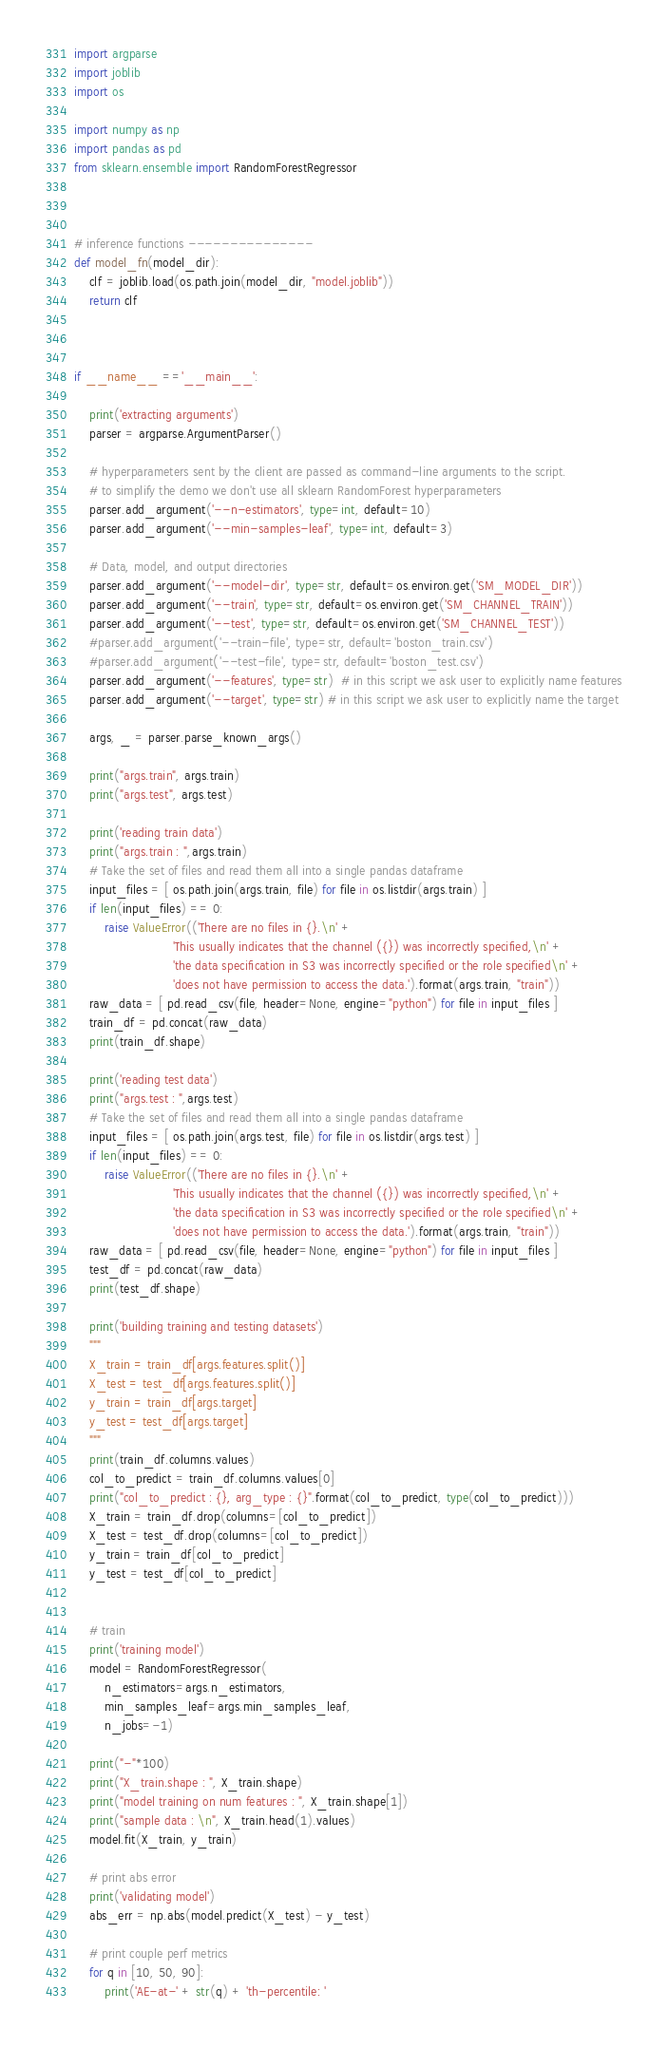<code> <loc_0><loc_0><loc_500><loc_500><_Python_>
import argparse
import joblib
import os

import numpy as np
import pandas as pd
from sklearn.ensemble import RandomForestRegressor



# inference functions ---------------
def model_fn(model_dir):
    clf = joblib.load(os.path.join(model_dir, "model.joblib"))
    return clf



if __name__ =='__main__':

    print('extracting arguments')
    parser = argparse.ArgumentParser()

    # hyperparameters sent by the client are passed as command-line arguments to the script.
    # to simplify the demo we don't use all sklearn RandomForest hyperparameters
    parser.add_argument('--n-estimators', type=int, default=10)
    parser.add_argument('--min-samples-leaf', type=int, default=3)

    # Data, model, and output directories
    parser.add_argument('--model-dir', type=str, default=os.environ.get('SM_MODEL_DIR'))
    parser.add_argument('--train', type=str, default=os.environ.get('SM_CHANNEL_TRAIN'))
    parser.add_argument('--test', type=str, default=os.environ.get('SM_CHANNEL_TEST'))
    #parser.add_argument('--train-file', type=str, default='boston_train.csv')
    #parser.add_argument('--test-file', type=str, default='boston_test.csv')
    parser.add_argument('--features', type=str)  # in this script we ask user to explicitly name features
    parser.add_argument('--target', type=str) # in this script we ask user to explicitly name the target

    args, _ = parser.parse_known_args()
    
    print("args.train", args.train)
    print("args.test", args.test)
    
    print('reading train data')
    print("args.train : ",args.train)
    # Take the set of files and read them all into a single pandas dataframe
    input_files = [ os.path.join(args.train, file) for file in os.listdir(args.train) ]
    if len(input_files) == 0:
        raise ValueError(('There are no files in {}.\n' +
                          'This usually indicates that the channel ({}) was incorrectly specified,\n' +
                          'the data specification in S3 was incorrectly specified or the role specified\n' +
                          'does not have permission to access the data.').format(args.train, "train"))
    raw_data = [ pd.read_csv(file, header=None, engine="python") for file in input_files ]
    train_df = pd.concat(raw_data)
    print(train_df.shape)
    
    print('reading test data')
    print("args.test : ",args.test)
    # Take the set of files and read them all into a single pandas dataframe
    input_files = [ os.path.join(args.test, file) for file in os.listdir(args.test) ]
    if len(input_files) == 0:
        raise ValueError(('There are no files in {}.\n' +
                          'This usually indicates that the channel ({}) was incorrectly specified,\n' +
                          'the data specification in S3 was incorrectly specified or the role specified\n' +
                          'does not have permission to access the data.').format(args.train, "train"))
    raw_data = [ pd.read_csv(file, header=None, engine="python") for file in input_files ]
    test_df = pd.concat(raw_data)
    print(test_df.shape)

    print('building training and testing datasets')
    """
    X_train = train_df[args.features.split()]
    X_test = test_df[args.features.split()]
    y_train = train_df[args.target]
    y_test = test_df[args.target]
    """
    print(train_df.columns.values)
    col_to_predict = train_df.columns.values[0]
    print("col_to_predict : {}, arg_type : {}".format(col_to_predict, type(col_to_predict)))
    X_train = train_df.drop(columns=[col_to_predict])
    X_test = test_df.drop(columns=[col_to_predict])
    y_train = train_df[col_to_predict]
    y_test = test_df[col_to_predict]
    
    
    # train
    print('training model')
    model = RandomForestRegressor(
        n_estimators=args.n_estimators,
        min_samples_leaf=args.min_samples_leaf,
        n_jobs=-1)
    
    print("-"*100)
    print("X_train.shape : ", X_train.shape)
    print("model training on num features : ", X_train.shape[1])
    print("sample data : \n", X_train.head(1).values)
    model.fit(X_train, y_train)

    # print abs error
    print('validating model')
    abs_err = np.abs(model.predict(X_test) - y_test)

    # print couple perf metrics
    for q in [10, 50, 90]:
        print('AE-at-' + str(q) + 'th-percentile: '</code> 